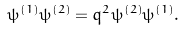<formula> <loc_0><loc_0><loc_500><loc_500>\psi ^ { ( 1 ) } \psi ^ { ( 2 ) } = q ^ { 2 } \psi ^ { ( 2 ) } \psi ^ { ( 1 ) } .</formula> 